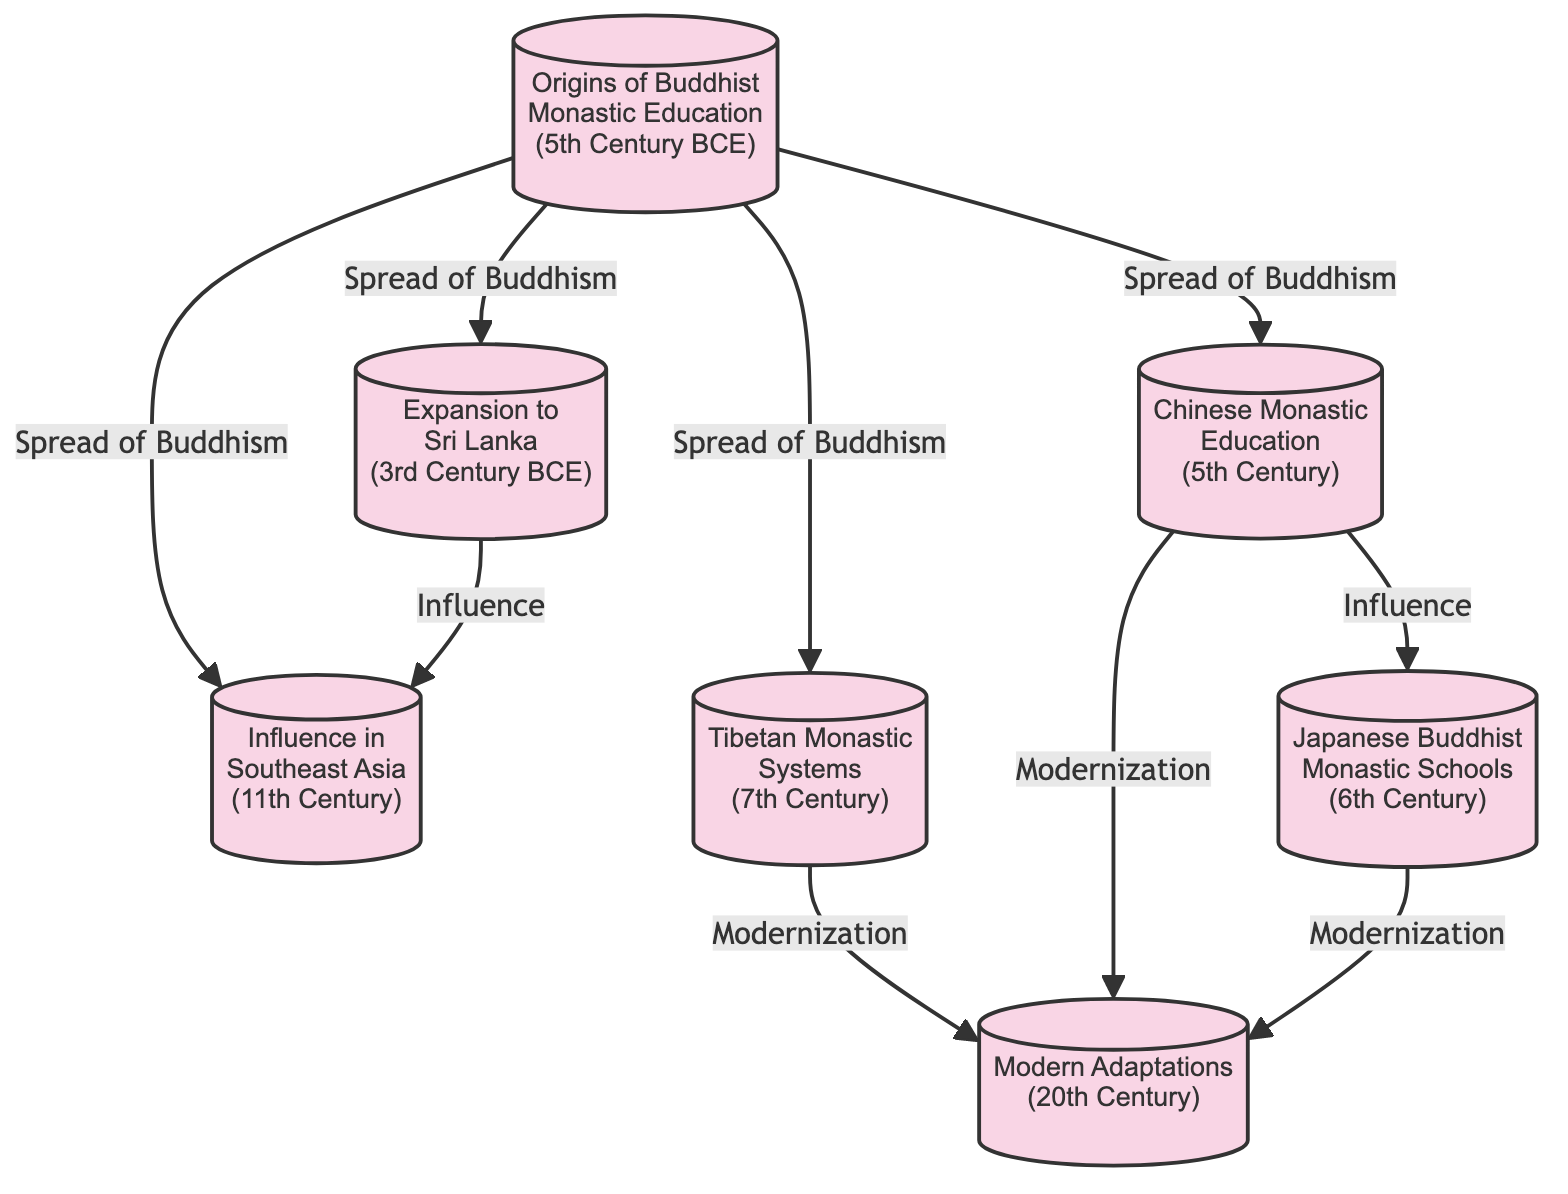What is the year associated with the "Origins of Buddhist Monastic Education"? The diagram indicates that the "Origins of Buddhist Monastic Education" occurred in the "5th Century BCE." This can be found directly beneath the node's label.
Answer: 5th Century BCE How many nodes are present in the diagram? Counting the distinct entries in the nodes section shows there are seven unique nodes, which represent different milestones in the development of Buddhist Monastic Educational Systems.
Answer: 7 Which node is connected to "Chinese Monastic Education"? The "Chinese Monastic Education" node (n5) has connections to "Japanese Buddhist Monastic Schools" (n6) and "Modern Adaptations" (n7) through an edge labeled "Influence" and "Modernization," respectively.
Answer: Japanese Buddhist Monastic Schools, Modern Adaptations What is the relationship between "Expansion to Sri Lanka" and "Influence in Southeast Asia"? The edge labeled "Influence" connects these two nodes: the "Expansion to Sri Lanka" node (n2) influences the "Influence in Southeast Asia" node (n3). This connection denotes a historical progression of influence stemming from Sri Lanka into Southeast Asia.
Answer: Influence How many relationships denote "Spread of Buddhism"? There are four edges labeled "Spread of Buddhism" connecting the "Origins of Buddhist Monastic Education" (n1) to "Expansion to Sri Lanka" (n2), "Tibetan Monastic Systems" (n4), "Chinese Monastic Education" (n5), and "Influence in Southeast Asia" (n3).
Answer: 4 Which nodes are involved in the "Modernization" relationships? The "Modernization" label has connections from the nodes "Tibetan Monastic Systems" (n4), "Chinese Monastic Education" (n5), and "Japanese Buddhist Monastic Schools" (n6) to the "Modern Adaptations" node (n7). This indicates contemporary changes stemming from these historical roots.
Answer: Tibetan Monastic Systems, Chinese Monastic Education, Japanese Buddhist Monastic Schools What is the earliest node in the diagram? The earliest node is "Origins of Buddhist Monastic Education" (n1) from the 5th Century BCE. It represents the foundational period of Buddhist education before expanding into various cultures.
Answer: Origins of Buddhist Monastic Education Which node has the latest development year? The latest node in the timeline is "Modern Adaptations," which is positioned in the 20th Century as a response to the evolving educational landscape within Buddhist contexts.
Answer: Modern Adaptations 